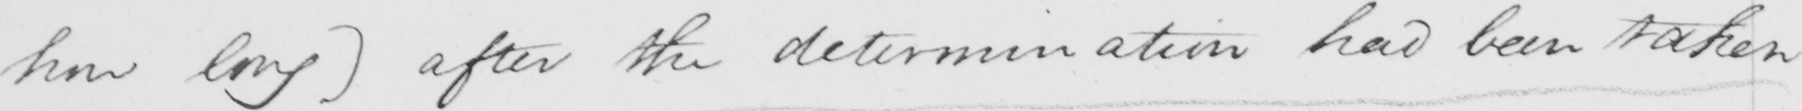Can you tell me what this handwritten text says? how long )  after the determination had been taken 